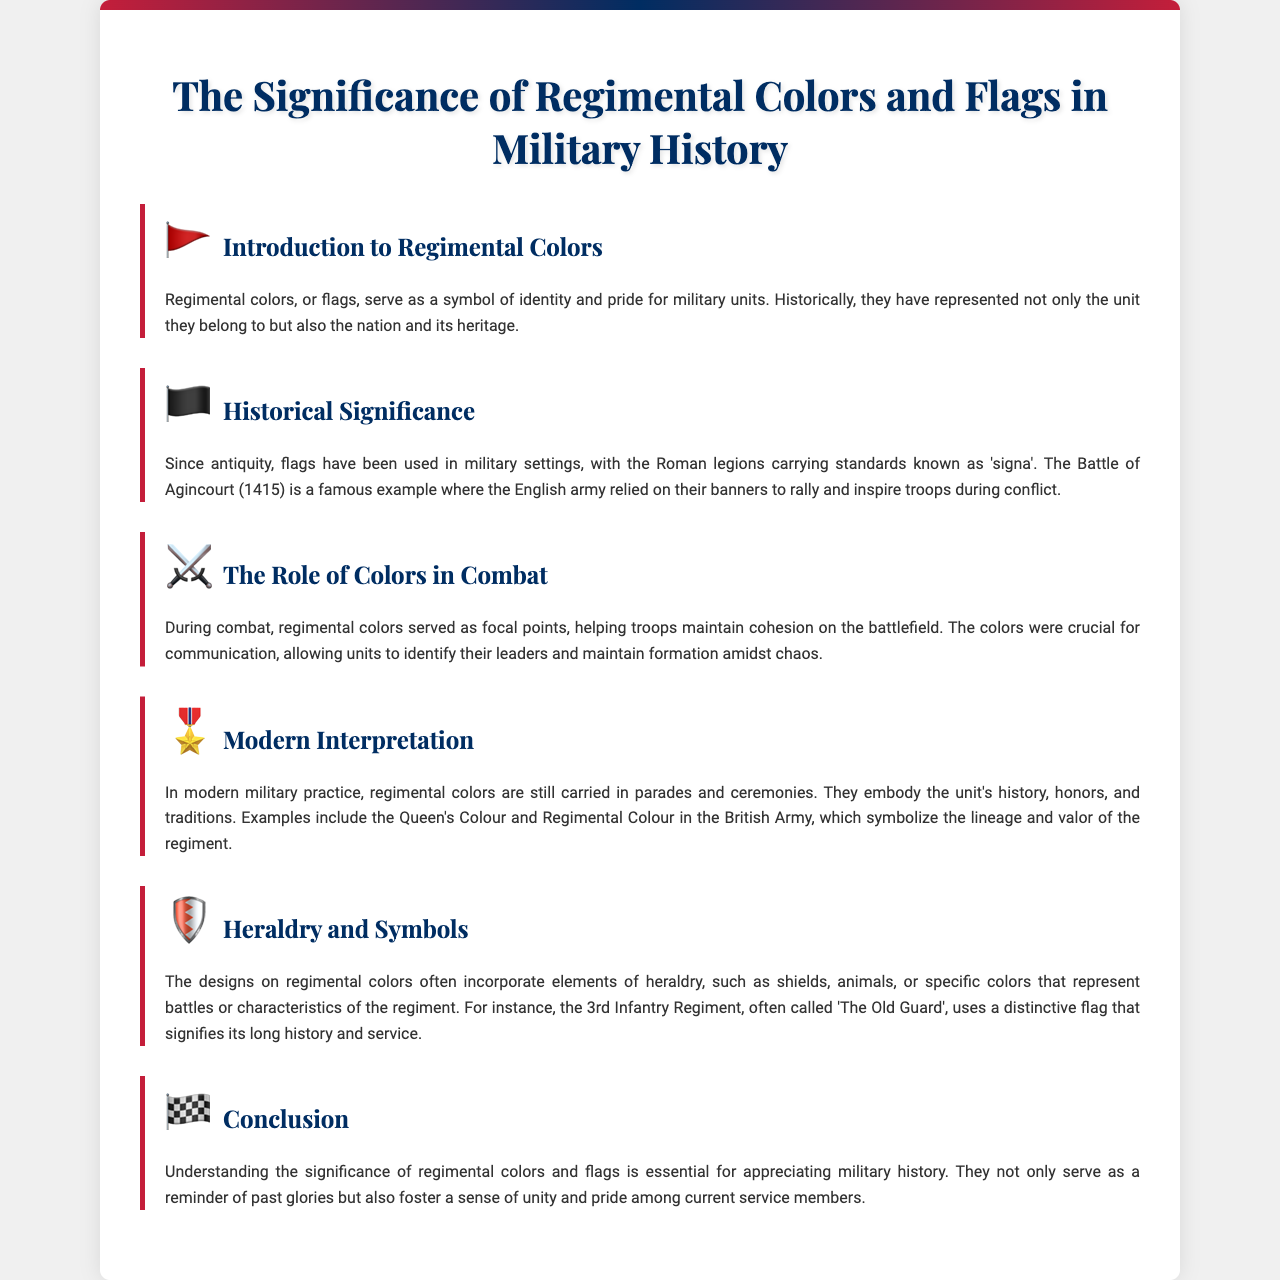What are regimental colors? Regimental colors, or flags, serve as a symbol of identity and pride for military units.
Answer: Symbols of identity and pride What battle is mentioned as a historical example? The Battle of Agincourt (1415) is referenced as a famous example where banners rallied troops.
Answer: Battle of Agincourt What role did regimental colors play during combat? Regimental colors served as focal points helping troops maintain cohesion on the battlefield.
Answer: Focal points for cohesion What are the two types of colors in the British Army? The document mentions the Queen's Colour and Regimental Colour as examples of modern military practice.
Answer: Queen's Colour and Regimental Colour What element do the designs on regimental colors often incorporate? The designs often incorporate elements of heraldry, such as shields and animals.
Answer: Heraldry What does understanding regimental colors help with? Understanding the significance of regimental colors is essential for appreciating military history.
Answer: Appreciating military history How do regimental colors foster unity? They foster a sense of unity and pride among current service members.
Answer: Sense of unity and pride 